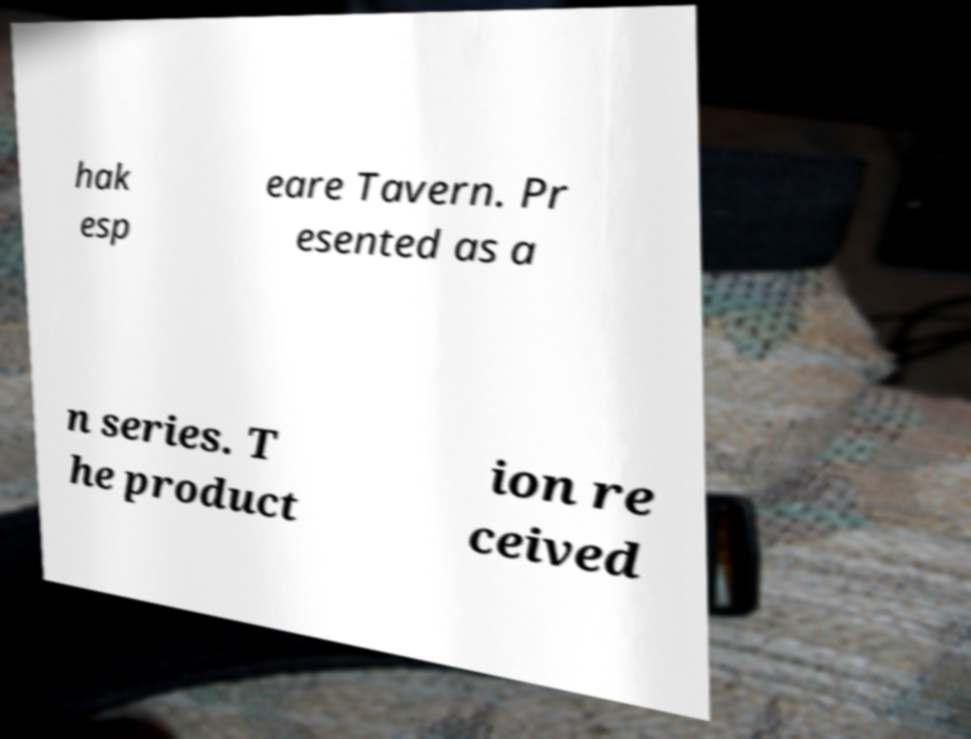Please read and relay the text visible in this image. What does it say? hak esp eare Tavern. Pr esented as a n series. T he product ion re ceived 